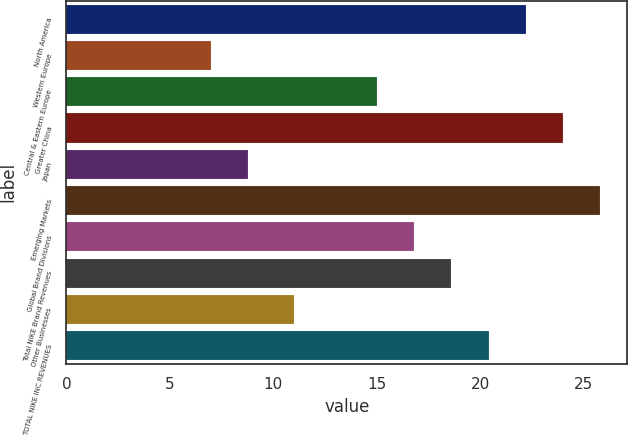Convert chart to OTSL. <chart><loc_0><loc_0><loc_500><loc_500><bar_chart><fcel>North America<fcel>Western Europe<fcel>Central & Eastern Europe<fcel>Greater China<fcel>Japan<fcel>Emerging Markets<fcel>Global Brand Divisions<fcel>Total NIKE Brand Revenues<fcel>Other Businesses<fcel>TOTAL NIKE INC REVENUES<nl><fcel>22.2<fcel>7<fcel>15<fcel>24<fcel>8.8<fcel>25.8<fcel>16.8<fcel>18.6<fcel>11<fcel>20.4<nl></chart> 